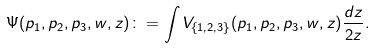<formula> <loc_0><loc_0><loc_500><loc_500>\Psi ( p _ { 1 } , p _ { 2 } , p _ { 3 } , w , z ) \colon = \int V _ { \{ 1 , 2 , 3 \} } ( p _ { 1 } , p _ { 2 } , p _ { 3 } , w , z ) \frac { d z } { 2 z } .</formula> 